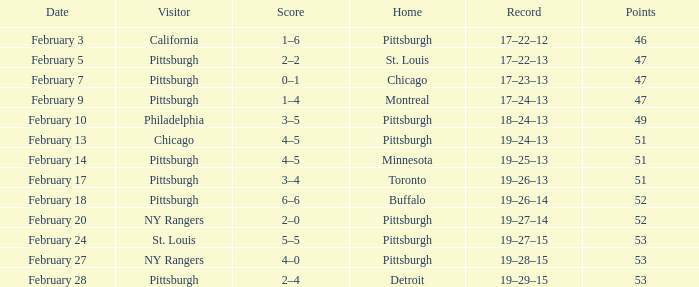Which score is dated february 9th? 1–4. 